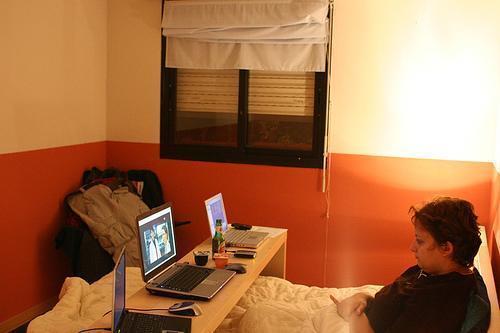What is the number of laptops sat on the bar held over this bed?
Answer the question by selecting the correct answer among the 4 following choices.
Options: Six, five, four, three. Three. 